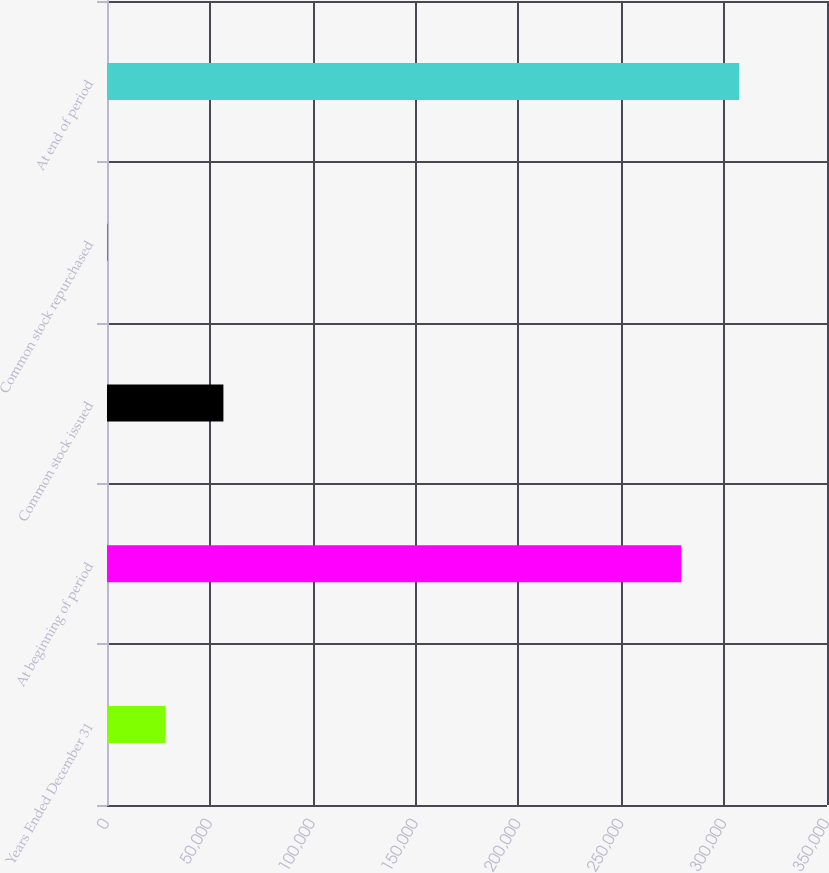Convert chart to OTSL. <chart><loc_0><loc_0><loc_500><loc_500><bar_chart><fcel>Years Ended December 31<fcel>At beginning of period<fcel>Common stock issued<fcel>Common stock repurchased<fcel>At end of period<nl><fcel>28450<fcel>279206<fcel>56583<fcel>317<fcel>307339<nl></chart> 